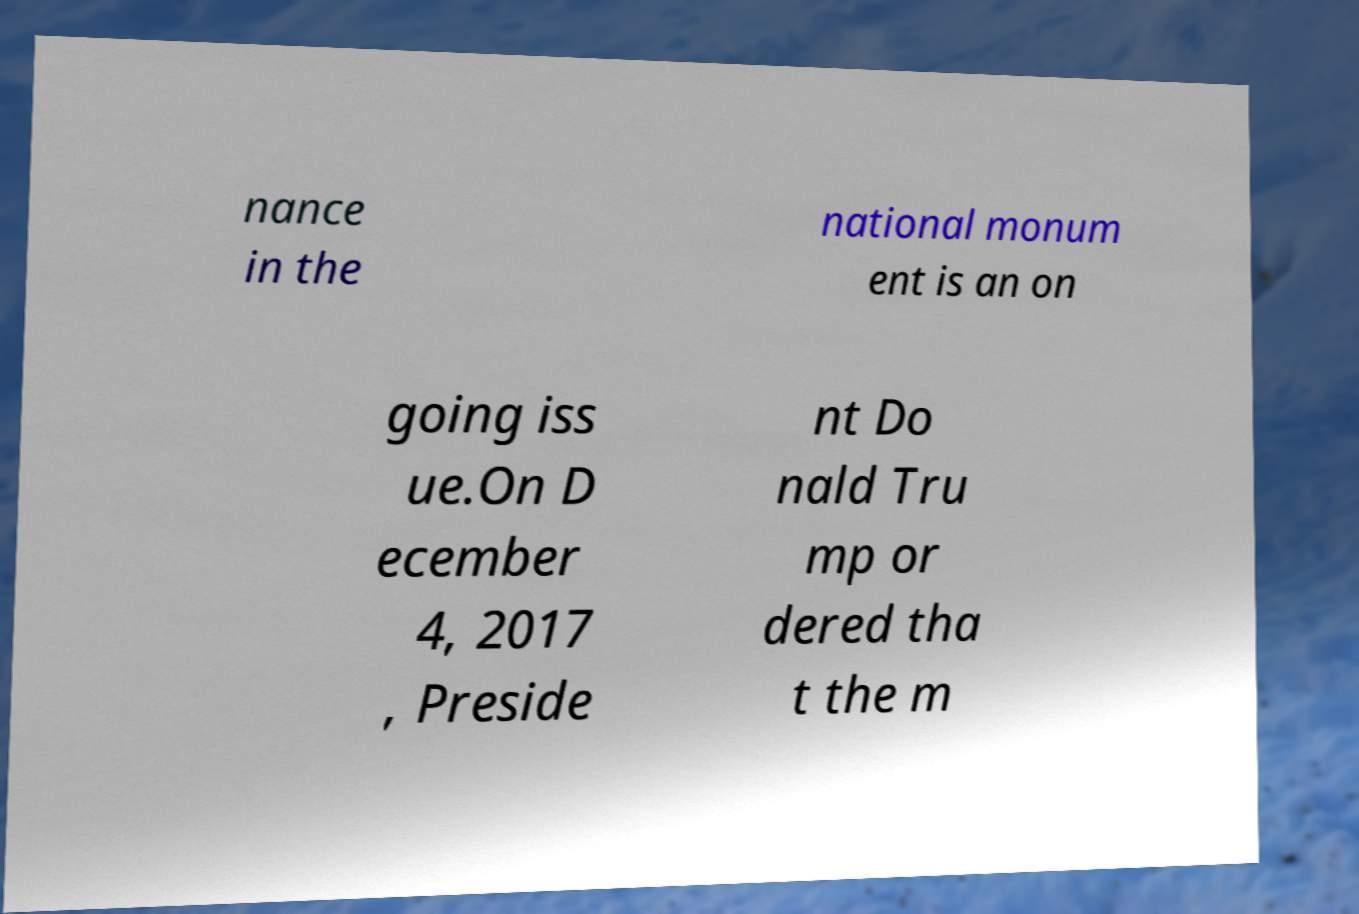Please read and relay the text visible in this image. What does it say? nance in the national monum ent is an on going iss ue.On D ecember 4, 2017 , Preside nt Do nald Tru mp or dered tha t the m 